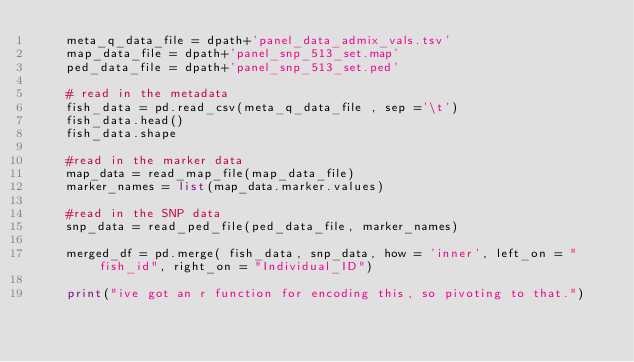Convert code to text. <code><loc_0><loc_0><loc_500><loc_500><_Python_>    meta_q_data_file = dpath+'panel_data_admix_vals.tsv'
    map_data_file = dpath+'panel_snp_513_set.map'
    ped_data_file = dpath+'panel_snp_513_set.ped'

    # read in the metadata
    fish_data = pd.read_csv(meta_q_data_file , sep ='\t')
    fish_data.head()
    fish_data.shape

    #read in the marker data
    map_data = read_map_file(map_data_file)
    marker_names = list(map_data.marker.values)

    #read in the SNP data
    snp_data = read_ped_file(ped_data_file, marker_names)

    merged_df = pd.merge( fish_data, snp_data, how = 'inner', left_on = "fish_id", right_on = "Individual_ID")

    print("ive got an r function for encoding this, so pivoting to that.")


    </code> 